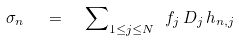Convert formula to latex. <formula><loc_0><loc_0><loc_500><loc_500>\sigma _ { n } \ \ = \ \ { \sum } _ { 1 \leq j \leq N } \ f _ { j } \, D _ { j } \, h _ { n , j }</formula> 